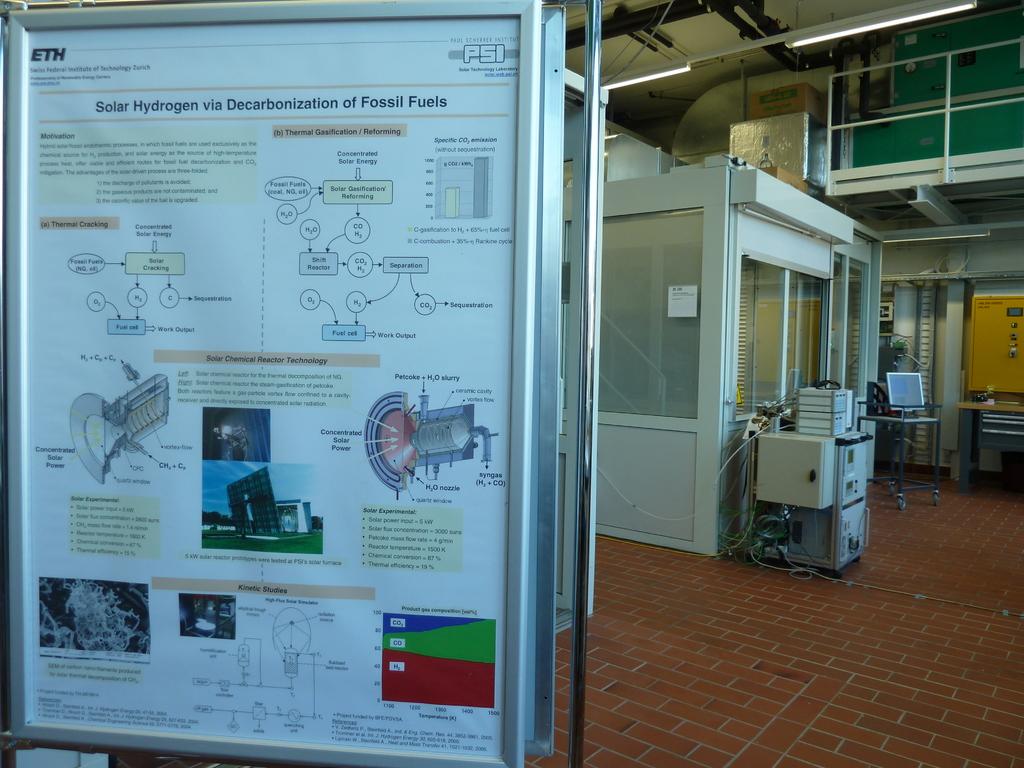What is the title of this board?
Provide a short and direct response. Solar hydrogen via decarbonization of fossil fuels. What three letters written in black can you see in the very top left?
Keep it short and to the point. Eth. 